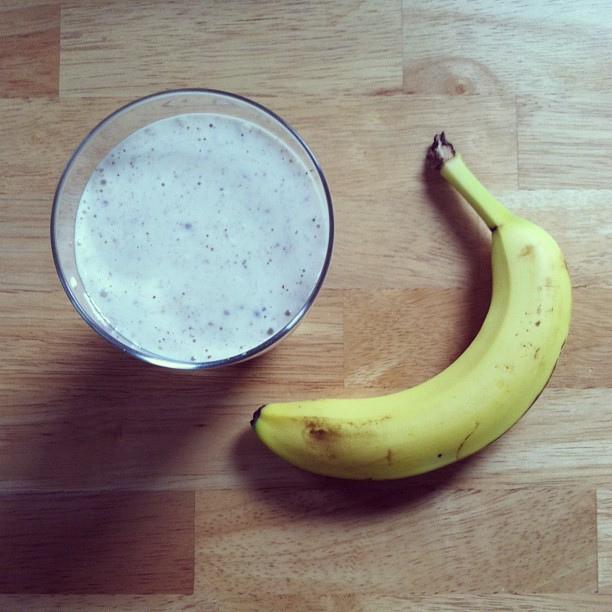What nutrient is this snack rich in?
Keep it brief. Potassium. What color is the table?
Quick response, please. Brown. Is this banana ripe?
Answer briefly. Yes. Is the banana in a plastic container?
Concise answer only. No. What is the number of bananas?
Be succinct. 1. How many bananas are in the photo?
Answer briefly. 1. 